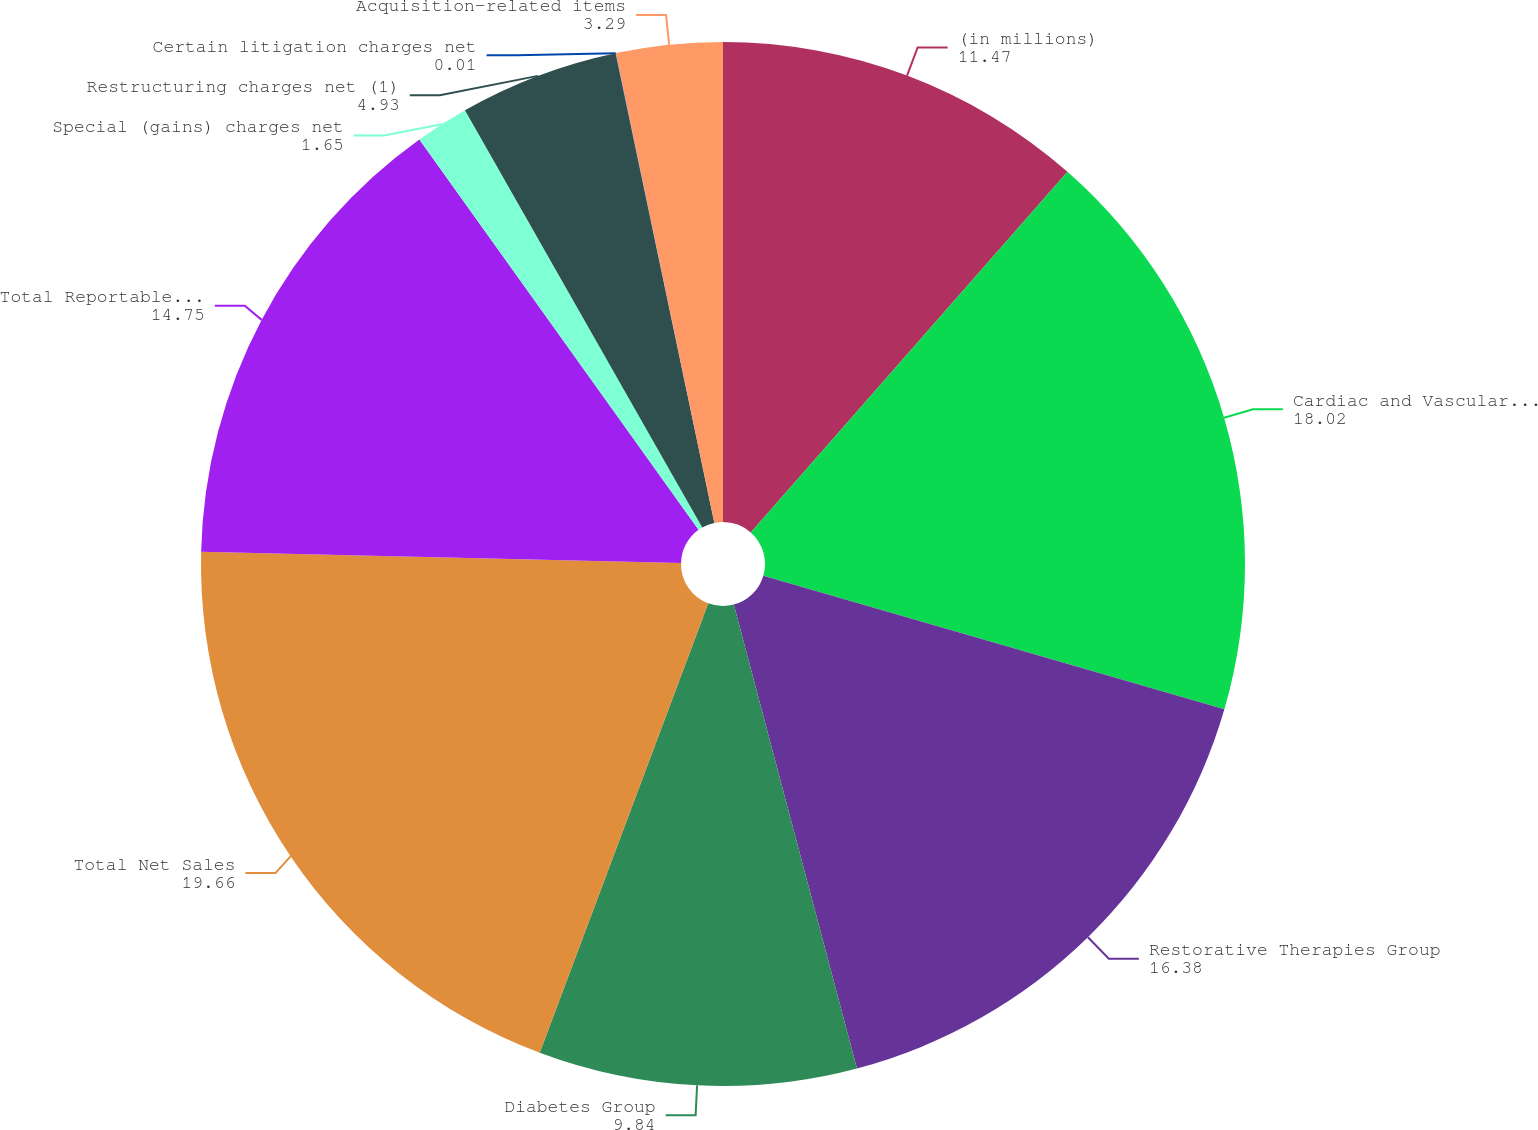Convert chart. <chart><loc_0><loc_0><loc_500><loc_500><pie_chart><fcel>(in millions)<fcel>Cardiac and Vascular Group<fcel>Restorative Therapies Group<fcel>Diabetes Group<fcel>Total Net Sales<fcel>Total Reportable Segments'<fcel>Special (gains) charges net<fcel>Restructuring charges net (1)<fcel>Certain litigation charges net<fcel>Acquisition-related items<nl><fcel>11.47%<fcel>18.02%<fcel>16.38%<fcel>9.84%<fcel>19.66%<fcel>14.75%<fcel>1.65%<fcel>4.93%<fcel>0.01%<fcel>3.29%<nl></chart> 